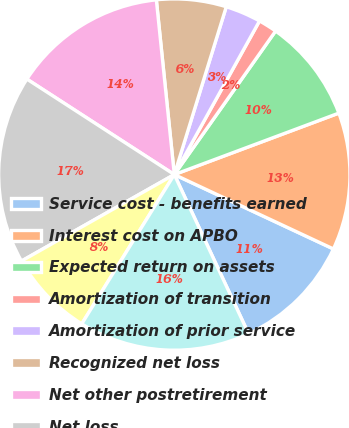Convert chart to OTSL. <chart><loc_0><loc_0><loc_500><loc_500><pie_chart><fcel>Service cost - benefits earned<fcel>Interest cost on APBO<fcel>Expected return on assets<fcel>Amortization of transition<fcel>Amortization of prior service<fcel>Recognized net loss<fcel>Net other postretirement<fcel>Net loss<fcel>Amortization of net loss<fcel>Total<nl><fcel>11.09%<fcel>12.65%<fcel>9.53%<fcel>1.72%<fcel>3.28%<fcel>6.41%<fcel>14.22%<fcel>17.34%<fcel>7.97%<fcel>15.78%<nl></chart> 